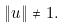Convert formula to latex. <formula><loc_0><loc_0><loc_500><loc_500>\| u \| \neq 1 .</formula> 